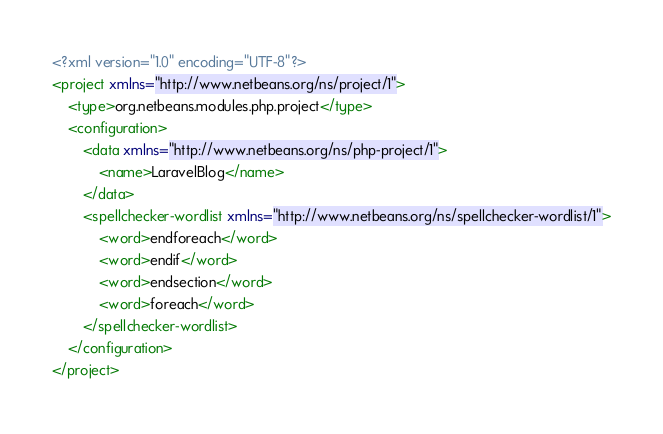<code> <loc_0><loc_0><loc_500><loc_500><_XML_><?xml version="1.0" encoding="UTF-8"?>
<project xmlns="http://www.netbeans.org/ns/project/1">
    <type>org.netbeans.modules.php.project</type>
    <configuration>
        <data xmlns="http://www.netbeans.org/ns/php-project/1">
            <name>LaravelBlog</name>
        </data>
        <spellchecker-wordlist xmlns="http://www.netbeans.org/ns/spellchecker-wordlist/1">
            <word>endforeach</word>
            <word>endif</word>
            <word>endsection</word>
            <word>foreach</word>
        </spellchecker-wordlist>
    </configuration>
</project>
</code> 